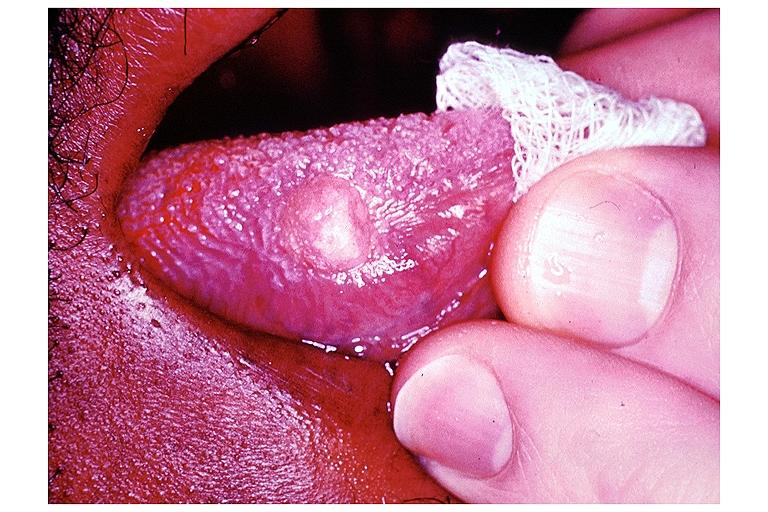does this image show granular cell tumor?
Answer the question using a single word or phrase. Yes 